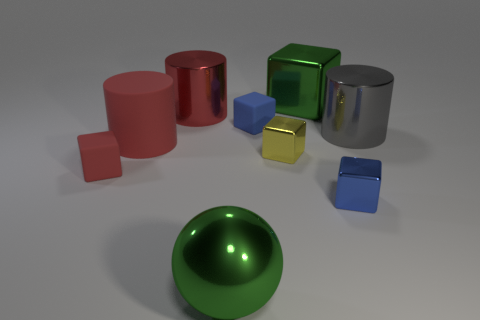There is a thing that is both in front of the red rubber cube and to the left of the small blue matte cube; what shape is it?
Your response must be concise. Sphere. The ball that is the same material as the small yellow object is what size?
Make the answer very short. Large. There is a ball; is it the same color as the tiny rubber block on the right side of the large shiny sphere?
Keep it short and to the point. No. What is the material of the big object that is behind the large gray cylinder and on the right side of the red metal cylinder?
Keep it short and to the point. Metal. There is a cylinder that is the same color as the big matte object; what is its size?
Your answer should be very brief. Large. There is a green metal object that is left of the green shiny cube; is its shape the same as the small thing to the right of the yellow metal block?
Provide a short and direct response. No. Are any shiny objects visible?
Provide a short and direct response. Yes. What color is the big metallic thing that is the same shape as the small yellow shiny thing?
Provide a short and direct response. Green. What is the color of the block that is the same size as the gray cylinder?
Ensure brevity in your answer.  Green. Are the red block and the gray cylinder made of the same material?
Your response must be concise. No. 